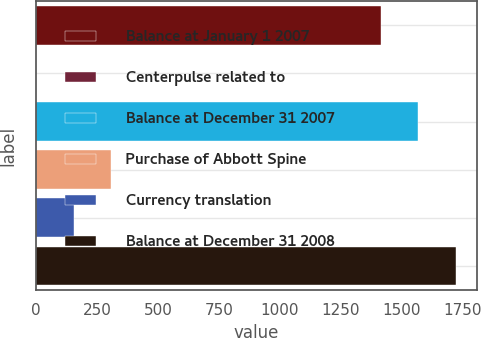Convert chart to OTSL. <chart><loc_0><loc_0><loc_500><loc_500><bar_chart><fcel>Balance at January 1 2007<fcel>Centerpulse related to<fcel>Balance at December 31 2007<fcel>Purchase of Abbott Spine<fcel>Currency translation<fcel>Balance at December 31 2008<nl><fcel>1414.1<fcel>0.1<fcel>1568.12<fcel>308.14<fcel>154.12<fcel>1722.14<nl></chart> 